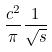<formula> <loc_0><loc_0><loc_500><loc_500>\frac { c ^ { 2 } } { \pi } \frac { 1 } { \sqrt { s } }</formula> 